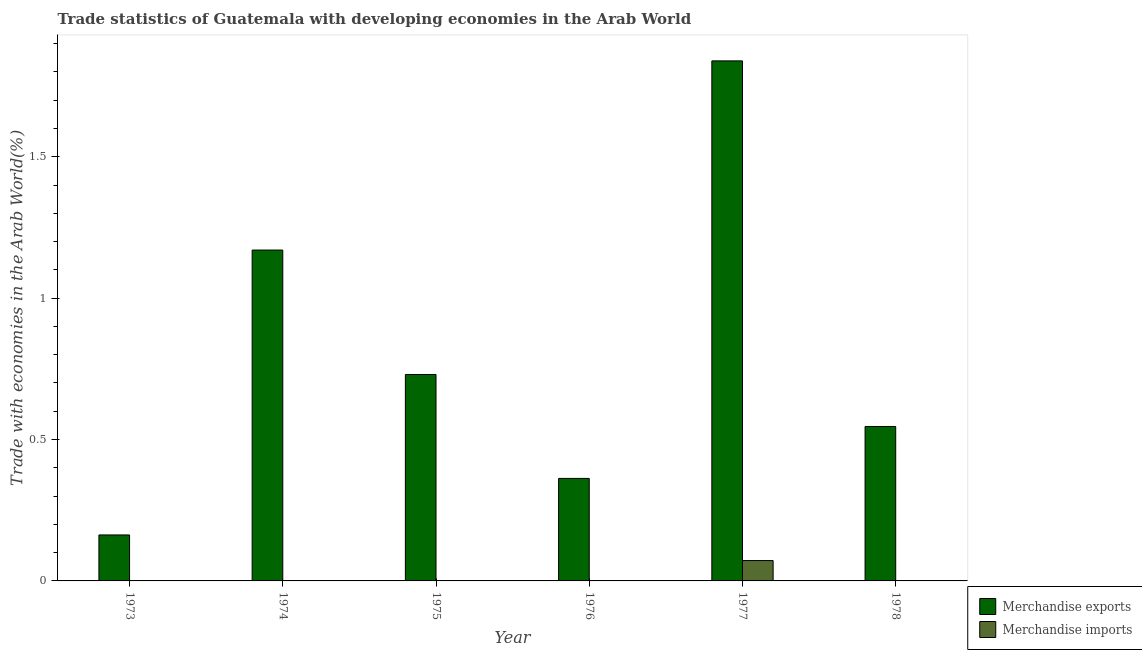How many groups of bars are there?
Offer a very short reply. 6. How many bars are there on the 1st tick from the left?
Offer a very short reply. 2. How many bars are there on the 4th tick from the right?
Your answer should be compact. 2. What is the label of the 6th group of bars from the left?
Make the answer very short. 1978. What is the merchandise exports in 1975?
Offer a very short reply. 0.73. Across all years, what is the maximum merchandise exports?
Offer a terse response. 1.84. Across all years, what is the minimum merchandise exports?
Give a very brief answer. 0.16. In which year was the merchandise imports maximum?
Your answer should be very brief. 1977. In which year was the merchandise imports minimum?
Keep it short and to the point. 1976. What is the total merchandise exports in the graph?
Provide a succinct answer. 4.81. What is the difference between the merchandise exports in 1974 and that in 1977?
Keep it short and to the point. -0.67. What is the difference between the merchandise imports in 1977 and the merchandise exports in 1978?
Your answer should be compact. 0.07. What is the average merchandise imports per year?
Your answer should be compact. 0.01. In the year 1974, what is the difference between the merchandise imports and merchandise exports?
Your answer should be very brief. 0. What is the ratio of the merchandise exports in 1974 to that in 1977?
Keep it short and to the point. 0.64. What is the difference between the highest and the second highest merchandise imports?
Ensure brevity in your answer.  0.07. What is the difference between the highest and the lowest merchandise imports?
Keep it short and to the point. 0.07. Is the sum of the merchandise imports in 1973 and 1974 greater than the maximum merchandise exports across all years?
Provide a short and direct response. No. How many bars are there?
Ensure brevity in your answer.  12. How many years are there in the graph?
Ensure brevity in your answer.  6. Does the graph contain grids?
Ensure brevity in your answer.  No. How many legend labels are there?
Your response must be concise. 2. What is the title of the graph?
Give a very brief answer. Trade statistics of Guatemala with developing economies in the Arab World. Does "Mobile cellular" appear as one of the legend labels in the graph?
Give a very brief answer. No. What is the label or title of the Y-axis?
Offer a terse response. Trade with economies in the Arab World(%). What is the Trade with economies in the Arab World(%) in Merchandise exports in 1973?
Keep it short and to the point. 0.16. What is the Trade with economies in the Arab World(%) in Merchandise imports in 1973?
Keep it short and to the point. 0. What is the Trade with economies in the Arab World(%) in Merchandise exports in 1974?
Your response must be concise. 1.17. What is the Trade with economies in the Arab World(%) of Merchandise imports in 1974?
Keep it short and to the point. 0. What is the Trade with economies in the Arab World(%) in Merchandise exports in 1975?
Your answer should be very brief. 0.73. What is the Trade with economies in the Arab World(%) in Merchandise imports in 1975?
Make the answer very short. 0. What is the Trade with economies in the Arab World(%) in Merchandise exports in 1976?
Make the answer very short. 0.36. What is the Trade with economies in the Arab World(%) in Merchandise imports in 1976?
Ensure brevity in your answer.  0. What is the Trade with economies in the Arab World(%) of Merchandise exports in 1977?
Your answer should be compact. 1.84. What is the Trade with economies in the Arab World(%) in Merchandise imports in 1977?
Give a very brief answer. 0.07. What is the Trade with economies in the Arab World(%) of Merchandise exports in 1978?
Your answer should be very brief. 0.55. What is the Trade with economies in the Arab World(%) in Merchandise imports in 1978?
Provide a short and direct response. 0. Across all years, what is the maximum Trade with economies in the Arab World(%) in Merchandise exports?
Give a very brief answer. 1.84. Across all years, what is the maximum Trade with economies in the Arab World(%) of Merchandise imports?
Keep it short and to the point. 0.07. Across all years, what is the minimum Trade with economies in the Arab World(%) of Merchandise exports?
Make the answer very short. 0.16. Across all years, what is the minimum Trade with economies in the Arab World(%) of Merchandise imports?
Your answer should be very brief. 0. What is the total Trade with economies in the Arab World(%) of Merchandise exports in the graph?
Offer a terse response. 4.81. What is the total Trade with economies in the Arab World(%) of Merchandise imports in the graph?
Provide a succinct answer. 0.08. What is the difference between the Trade with economies in the Arab World(%) of Merchandise exports in 1973 and that in 1974?
Your response must be concise. -1.01. What is the difference between the Trade with economies in the Arab World(%) of Merchandise exports in 1973 and that in 1975?
Your answer should be very brief. -0.57. What is the difference between the Trade with economies in the Arab World(%) of Merchandise imports in 1973 and that in 1975?
Give a very brief answer. -0. What is the difference between the Trade with economies in the Arab World(%) of Merchandise exports in 1973 and that in 1976?
Offer a terse response. -0.2. What is the difference between the Trade with economies in the Arab World(%) in Merchandise imports in 1973 and that in 1976?
Your response must be concise. 0. What is the difference between the Trade with economies in the Arab World(%) of Merchandise exports in 1973 and that in 1977?
Provide a succinct answer. -1.68. What is the difference between the Trade with economies in the Arab World(%) in Merchandise imports in 1973 and that in 1977?
Make the answer very short. -0.07. What is the difference between the Trade with economies in the Arab World(%) in Merchandise exports in 1973 and that in 1978?
Give a very brief answer. -0.38. What is the difference between the Trade with economies in the Arab World(%) in Merchandise imports in 1973 and that in 1978?
Give a very brief answer. 0. What is the difference between the Trade with economies in the Arab World(%) of Merchandise exports in 1974 and that in 1975?
Offer a very short reply. 0.44. What is the difference between the Trade with economies in the Arab World(%) in Merchandise imports in 1974 and that in 1975?
Offer a terse response. -0. What is the difference between the Trade with economies in the Arab World(%) in Merchandise exports in 1974 and that in 1976?
Provide a succinct answer. 0.81. What is the difference between the Trade with economies in the Arab World(%) of Merchandise exports in 1974 and that in 1977?
Give a very brief answer. -0.67. What is the difference between the Trade with economies in the Arab World(%) of Merchandise imports in 1974 and that in 1977?
Keep it short and to the point. -0.07. What is the difference between the Trade with economies in the Arab World(%) in Merchandise exports in 1974 and that in 1978?
Give a very brief answer. 0.62. What is the difference between the Trade with economies in the Arab World(%) in Merchandise imports in 1974 and that in 1978?
Offer a very short reply. 0. What is the difference between the Trade with economies in the Arab World(%) in Merchandise exports in 1975 and that in 1976?
Your response must be concise. 0.37. What is the difference between the Trade with economies in the Arab World(%) in Merchandise imports in 1975 and that in 1976?
Keep it short and to the point. 0. What is the difference between the Trade with economies in the Arab World(%) of Merchandise exports in 1975 and that in 1977?
Give a very brief answer. -1.11. What is the difference between the Trade with economies in the Arab World(%) of Merchandise imports in 1975 and that in 1977?
Offer a very short reply. -0.07. What is the difference between the Trade with economies in the Arab World(%) in Merchandise exports in 1975 and that in 1978?
Give a very brief answer. 0.18. What is the difference between the Trade with economies in the Arab World(%) in Merchandise imports in 1975 and that in 1978?
Your answer should be compact. 0. What is the difference between the Trade with economies in the Arab World(%) of Merchandise exports in 1976 and that in 1977?
Provide a succinct answer. -1.48. What is the difference between the Trade with economies in the Arab World(%) of Merchandise imports in 1976 and that in 1977?
Your answer should be compact. -0.07. What is the difference between the Trade with economies in the Arab World(%) of Merchandise exports in 1976 and that in 1978?
Your response must be concise. -0.18. What is the difference between the Trade with economies in the Arab World(%) in Merchandise imports in 1976 and that in 1978?
Offer a terse response. -0. What is the difference between the Trade with economies in the Arab World(%) of Merchandise exports in 1977 and that in 1978?
Provide a succinct answer. 1.29. What is the difference between the Trade with economies in the Arab World(%) of Merchandise imports in 1977 and that in 1978?
Keep it short and to the point. 0.07. What is the difference between the Trade with economies in the Arab World(%) in Merchandise exports in 1973 and the Trade with economies in the Arab World(%) in Merchandise imports in 1974?
Ensure brevity in your answer.  0.16. What is the difference between the Trade with economies in the Arab World(%) in Merchandise exports in 1973 and the Trade with economies in the Arab World(%) in Merchandise imports in 1975?
Provide a succinct answer. 0.16. What is the difference between the Trade with economies in the Arab World(%) in Merchandise exports in 1973 and the Trade with economies in the Arab World(%) in Merchandise imports in 1976?
Your answer should be compact. 0.16. What is the difference between the Trade with economies in the Arab World(%) of Merchandise exports in 1973 and the Trade with economies in the Arab World(%) of Merchandise imports in 1977?
Ensure brevity in your answer.  0.09. What is the difference between the Trade with economies in the Arab World(%) of Merchandise exports in 1973 and the Trade with economies in the Arab World(%) of Merchandise imports in 1978?
Ensure brevity in your answer.  0.16. What is the difference between the Trade with economies in the Arab World(%) of Merchandise exports in 1974 and the Trade with economies in the Arab World(%) of Merchandise imports in 1975?
Give a very brief answer. 1.17. What is the difference between the Trade with economies in the Arab World(%) in Merchandise exports in 1974 and the Trade with economies in the Arab World(%) in Merchandise imports in 1976?
Your response must be concise. 1.17. What is the difference between the Trade with economies in the Arab World(%) of Merchandise exports in 1974 and the Trade with economies in the Arab World(%) of Merchandise imports in 1977?
Ensure brevity in your answer.  1.1. What is the difference between the Trade with economies in the Arab World(%) of Merchandise exports in 1974 and the Trade with economies in the Arab World(%) of Merchandise imports in 1978?
Give a very brief answer. 1.17. What is the difference between the Trade with economies in the Arab World(%) of Merchandise exports in 1975 and the Trade with economies in the Arab World(%) of Merchandise imports in 1976?
Offer a very short reply. 0.73. What is the difference between the Trade with economies in the Arab World(%) in Merchandise exports in 1975 and the Trade with economies in the Arab World(%) in Merchandise imports in 1977?
Give a very brief answer. 0.66. What is the difference between the Trade with economies in the Arab World(%) of Merchandise exports in 1975 and the Trade with economies in the Arab World(%) of Merchandise imports in 1978?
Make the answer very short. 0.73. What is the difference between the Trade with economies in the Arab World(%) of Merchandise exports in 1976 and the Trade with economies in the Arab World(%) of Merchandise imports in 1977?
Keep it short and to the point. 0.29. What is the difference between the Trade with economies in the Arab World(%) in Merchandise exports in 1976 and the Trade with economies in the Arab World(%) in Merchandise imports in 1978?
Offer a very short reply. 0.36. What is the difference between the Trade with economies in the Arab World(%) in Merchandise exports in 1977 and the Trade with economies in the Arab World(%) in Merchandise imports in 1978?
Keep it short and to the point. 1.84. What is the average Trade with economies in the Arab World(%) of Merchandise exports per year?
Your answer should be compact. 0.8. What is the average Trade with economies in the Arab World(%) of Merchandise imports per year?
Provide a succinct answer. 0.01. In the year 1973, what is the difference between the Trade with economies in the Arab World(%) in Merchandise exports and Trade with economies in the Arab World(%) in Merchandise imports?
Offer a very short reply. 0.16. In the year 1974, what is the difference between the Trade with economies in the Arab World(%) of Merchandise exports and Trade with economies in the Arab World(%) of Merchandise imports?
Ensure brevity in your answer.  1.17. In the year 1975, what is the difference between the Trade with economies in the Arab World(%) of Merchandise exports and Trade with economies in the Arab World(%) of Merchandise imports?
Give a very brief answer. 0.73. In the year 1976, what is the difference between the Trade with economies in the Arab World(%) in Merchandise exports and Trade with economies in the Arab World(%) in Merchandise imports?
Provide a succinct answer. 0.36. In the year 1977, what is the difference between the Trade with economies in the Arab World(%) in Merchandise exports and Trade with economies in the Arab World(%) in Merchandise imports?
Offer a terse response. 1.77. In the year 1978, what is the difference between the Trade with economies in the Arab World(%) in Merchandise exports and Trade with economies in the Arab World(%) in Merchandise imports?
Your answer should be compact. 0.55. What is the ratio of the Trade with economies in the Arab World(%) in Merchandise exports in 1973 to that in 1974?
Offer a very short reply. 0.14. What is the ratio of the Trade with economies in the Arab World(%) of Merchandise imports in 1973 to that in 1974?
Make the answer very short. 1.63. What is the ratio of the Trade with economies in the Arab World(%) of Merchandise exports in 1973 to that in 1975?
Provide a succinct answer. 0.22. What is the ratio of the Trade with economies in the Arab World(%) of Merchandise imports in 1973 to that in 1975?
Your answer should be compact. 0.95. What is the ratio of the Trade with economies in the Arab World(%) of Merchandise exports in 1973 to that in 1976?
Offer a very short reply. 0.45. What is the ratio of the Trade with economies in the Arab World(%) of Merchandise imports in 1973 to that in 1976?
Your answer should be very brief. 4.87. What is the ratio of the Trade with economies in the Arab World(%) in Merchandise exports in 1973 to that in 1977?
Your response must be concise. 0.09. What is the ratio of the Trade with economies in the Arab World(%) in Merchandise imports in 1973 to that in 1977?
Give a very brief answer. 0.02. What is the ratio of the Trade with economies in the Arab World(%) of Merchandise exports in 1973 to that in 1978?
Keep it short and to the point. 0.3. What is the ratio of the Trade with economies in the Arab World(%) in Merchandise imports in 1973 to that in 1978?
Give a very brief answer. 1.87. What is the ratio of the Trade with economies in the Arab World(%) of Merchandise exports in 1974 to that in 1975?
Offer a terse response. 1.6. What is the ratio of the Trade with economies in the Arab World(%) in Merchandise imports in 1974 to that in 1975?
Your response must be concise. 0.58. What is the ratio of the Trade with economies in the Arab World(%) in Merchandise exports in 1974 to that in 1976?
Your answer should be very brief. 3.23. What is the ratio of the Trade with economies in the Arab World(%) of Merchandise imports in 1974 to that in 1976?
Ensure brevity in your answer.  2.99. What is the ratio of the Trade with economies in the Arab World(%) in Merchandise exports in 1974 to that in 1977?
Your response must be concise. 0.64. What is the ratio of the Trade with economies in the Arab World(%) of Merchandise imports in 1974 to that in 1977?
Provide a succinct answer. 0.01. What is the ratio of the Trade with economies in the Arab World(%) of Merchandise exports in 1974 to that in 1978?
Offer a very short reply. 2.14. What is the ratio of the Trade with economies in the Arab World(%) of Merchandise imports in 1974 to that in 1978?
Make the answer very short. 1.15. What is the ratio of the Trade with economies in the Arab World(%) in Merchandise exports in 1975 to that in 1976?
Make the answer very short. 2.01. What is the ratio of the Trade with economies in the Arab World(%) of Merchandise imports in 1975 to that in 1976?
Offer a terse response. 5.15. What is the ratio of the Trade with economies in the Arab World(%) in Merchandise exports in 1975 to that in 1977?
Offer a very short reply. 0.4. What is the ratio of the Trade with economies in the Arab World(%) in Merchandise imports in 1975 to that in 1977?
Make the answer very short. 0.02. What is the ratio of the Trade with economies in the Arab World(%) of Merchandise exports in 1975 to that in 1978?
Give a very brief answer. 1.34. What is the ratio of the Trade with economies in the Arab World(%) of Merchandise imports in 1975 to that in 1978?
Provide a succinct answer. 1.97. What is the ratio of the Trade with economies in the Arab World(%) of Merchandise exports in 1976 to that in 1977?
Your answer should be very brief. 0.2. What is the ratio of the Trade with economies in the Arab World(%) in Merchandise imports in 1976 to that in 1977?
Ensure brevity in your answer.  0. What is the ratio of the Trade with economies in the Arab World(%) of Merchandise exports in 1976 to that in 1978?
Your answer should be compact. 0.66. What is the ratio of the Trade with economies in the Arab World(%) of Merchandise imports in 1976 to that in 1978?
Provide a succinct answer. 0.38. What is the ratio of the Trade with economies in the Arab World(%) in Merchandise exports in 1977 to that in 1978?
Offer a very short reply. 3.37. What is the ratio of the Trade with economies in the Arab World(%) of Merchandise imports in 1977 to that in 1978?
Your answer should be very brief. 115.66. What is the difference between the highest and the second highest Trade with economies in the Arab World(%) in Merchandise exports?
Provide a short and direct response. 0.67. What is the difference between the highest and the second highest Trade with economies in the Arab World(%) of Merchandise imports?
Give a very brief answer. 0.07. What is the difference between the highest and the lowest Trade with economies in the Arab World(%) in Merchandise exports?
Provide a short and direct response. 1.68. What is the difference between the highest and the lowest Trade with economies in the Arab World(%) in Merchandise imports?
Offer a terse response. 0.07. 